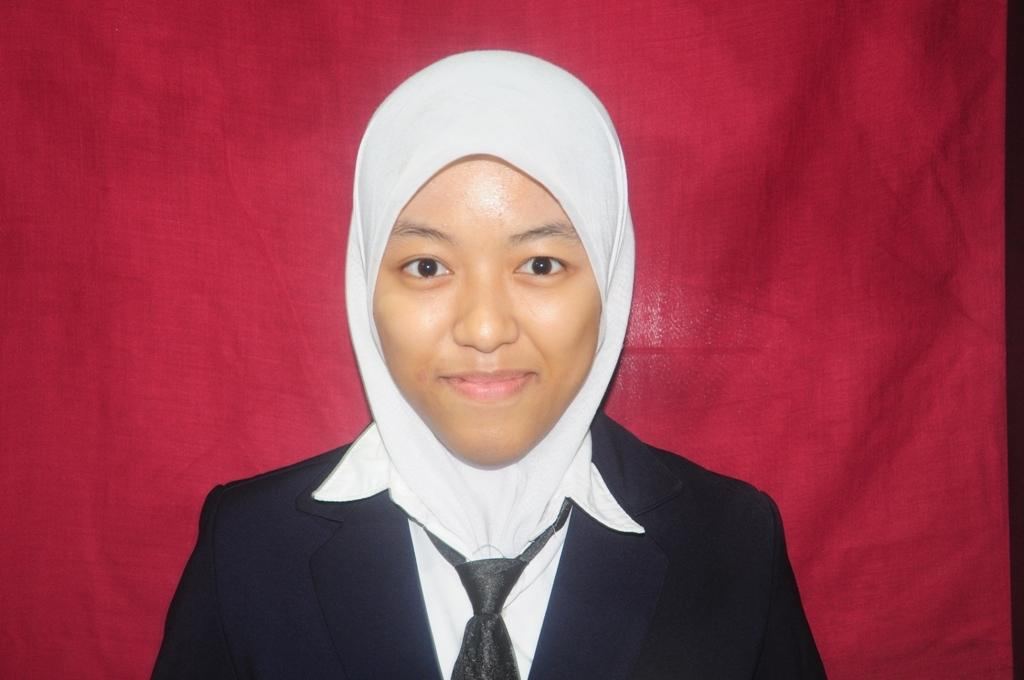Who is present in the image? There is a woman in the image. What is the woman wearing on her head? The woman is wearing a hijab. What color is the cloth visible behind the woman? The cloth visible behind the woman is a red cloth. Can you tell me how many horses are present in the image? There are no horses present in the image; it features a woman wearing a hijab with a red cloth visible behind her. What type of church can be seen in the image? There is no church present in the image. 